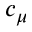Convert formula to latex. <formula><loc_0><loc_0><loc_500><loc_500>c _ { \mu }</formula> 